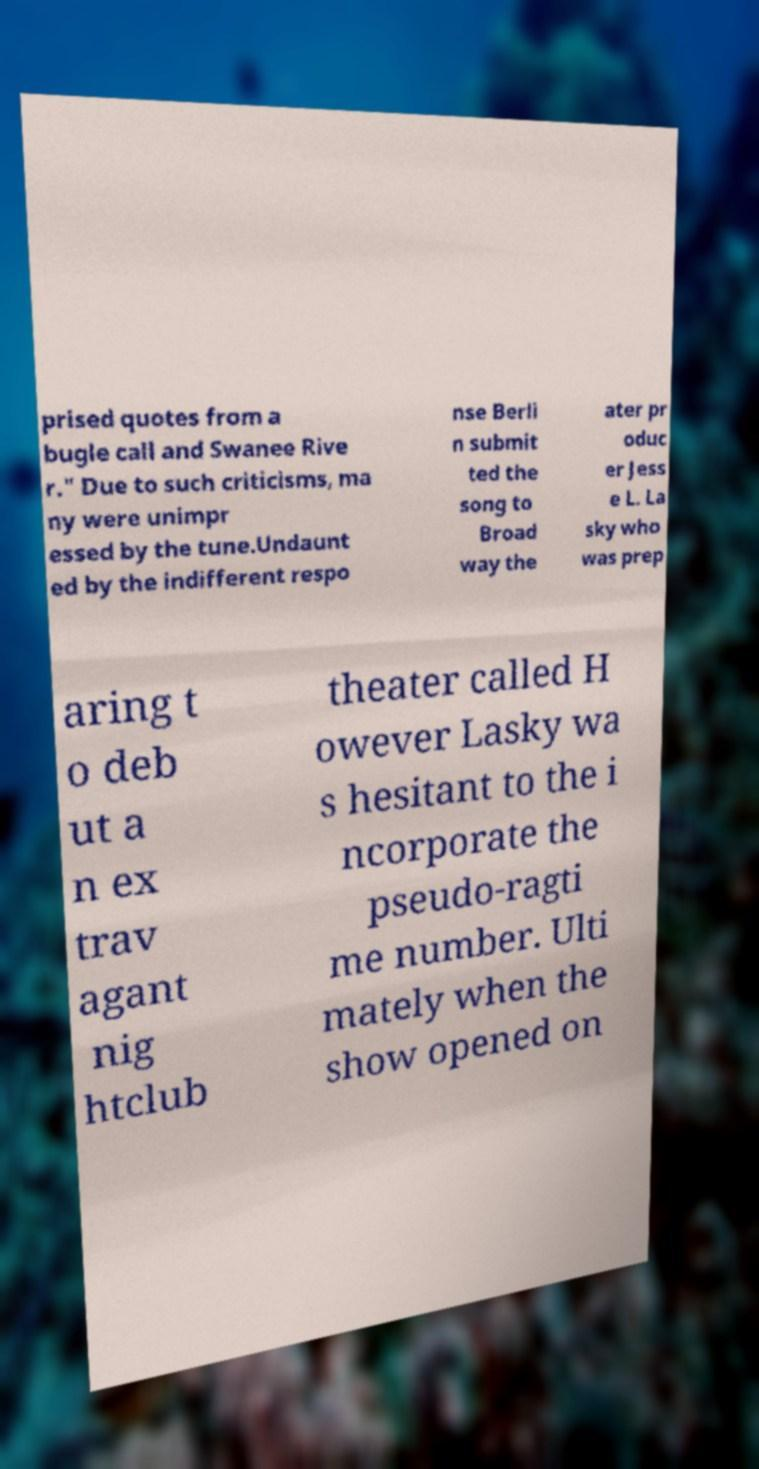Can you read and provide the text displayed in the image?This photo seems to have some interesting text. Can you extract and type it out for me? prised quotes from a bugle call and Swanee Rive r." Due to such criticisms, ma ny were unimpr essed by the tune.Undaunt ed by the indifferent respo nse Berli n submit ted the song to Broad way the ater pr oduc er Jess e L. La sky who was prep aring t o deb ut a n ex trav agant nig htclub theater called H owever Lasky wa s hesitant to the i ncorporate the pseudo-ragti me number. Ulti mately when the show opened on 